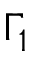<formula> <loc_0><loc_0><loc_500><loc_500>\Gamma _ { 1 }</formula> 